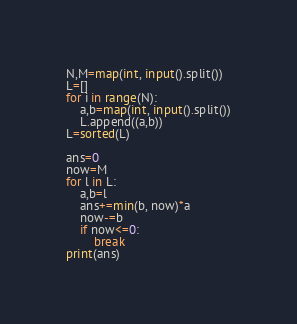Convert code to text. <code><loc_0><loc_0><loc_500><loc_500><_Python_>N,M=map(int, input().split())
L=[]
for i in range(N):
    a,b=map(int, input().split())
    L.append((a,b))
L=sorted(L)

ans=0
now=M
for l in L:
    a,b=l
    ans+=min(b, now)*a
    now-=b
    if now<=0:
        break
print(ans)</code> 